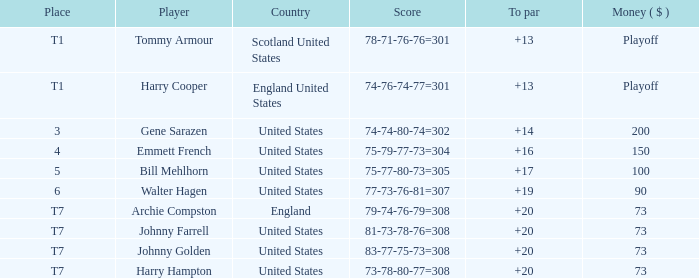What is the ranking when Archie Compston is the player and the money is $73? T7. 